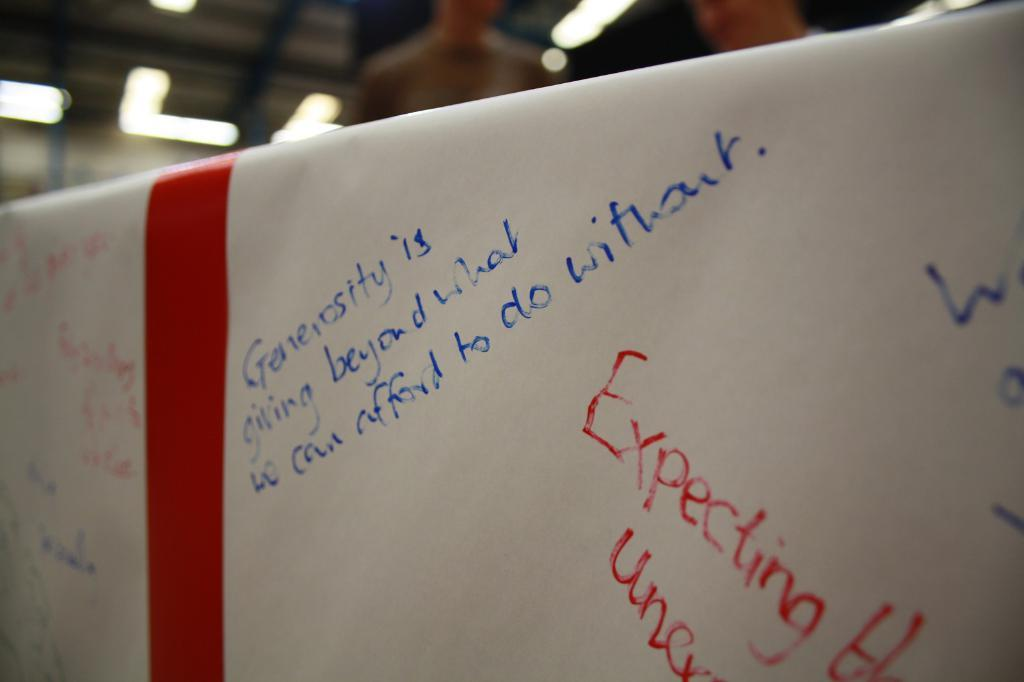Provide a one-sentence caption for the provided image. Generosity is giving beyond and Expecting words wrote on a white poster. 